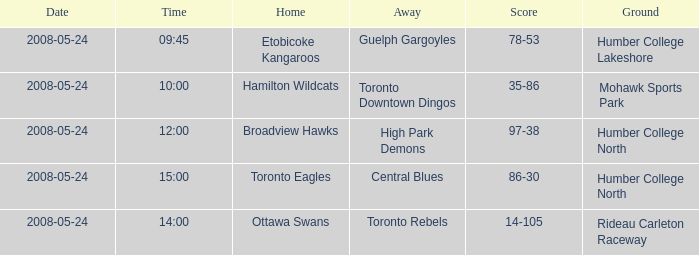On what day was the game that ended in a score of 97-38? 2008-05-24. 